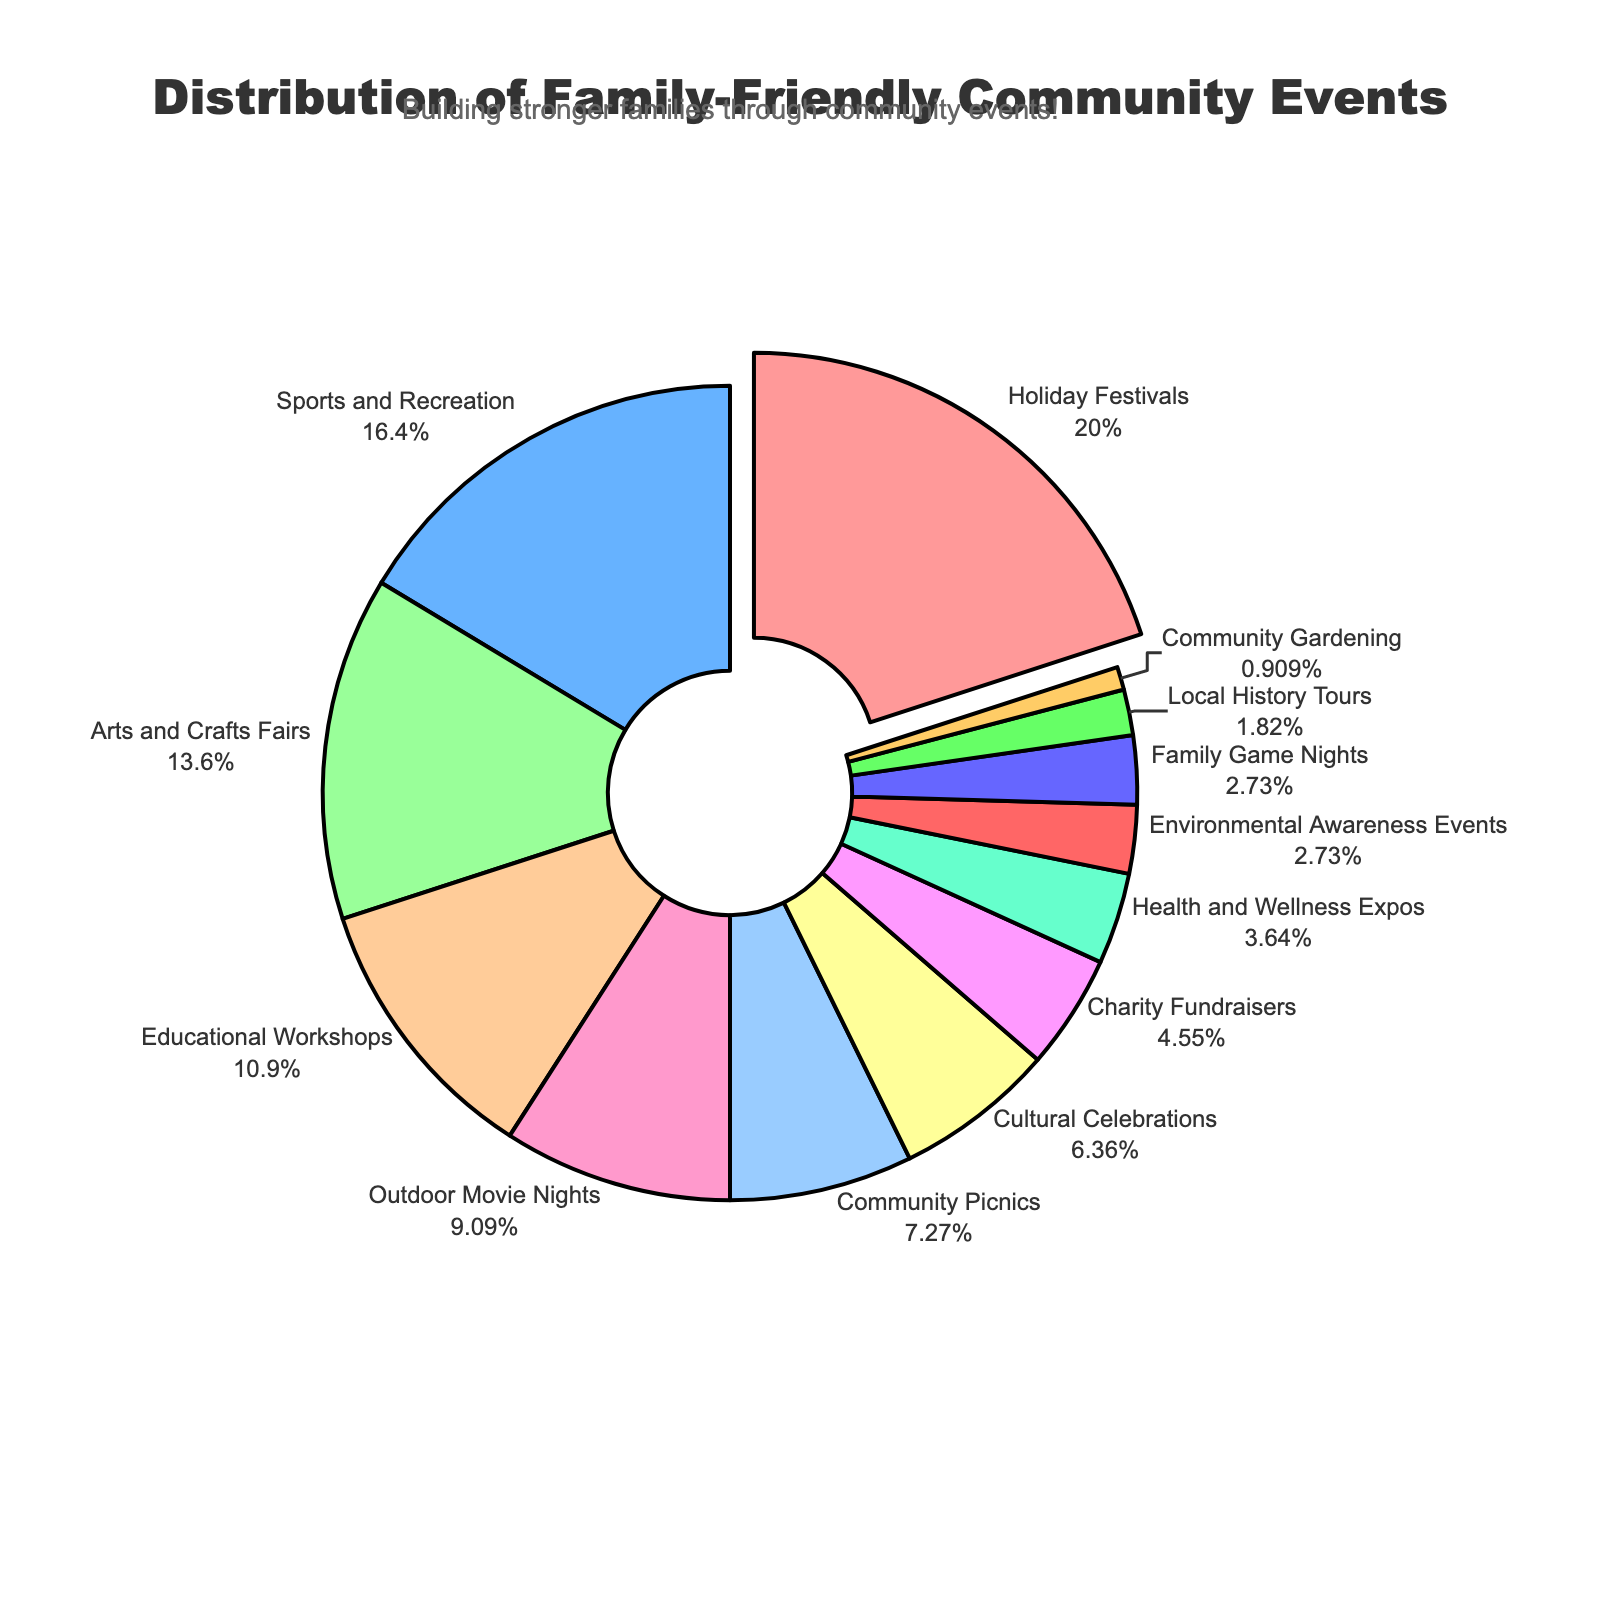What category has the largest percentage of events? The slice that is pulled slightly away from the pie represents the category with the largest percentage. This slice shows "Holiday Festivals" with 22%.
Answer: Holiday Festivals Which category has a smaller percentage, Sports and Recreation or Educational Workshops? "Sports and Recreation" has an 18% share, whereas "Educational Workshops" have a 12% share. Thus, Sports and Recreation has a larger percentage than Educational Workshops.
Answer: Educational Workshops What is the combined percentage of Community Picnics and Outdoor Movie Nights? Community Picnics account for 8%, and Outdoor Movie Nights account for 10%. Adding these two percentages gives 8% + 10% = 18%.
Answer: 18% How much larger is the percentage of Holiday Festivals compared to Charity Fundraisers? Holiday Festivals have a 22% share, while Charity Fundraisers have a 5% share. The difference between these percentages is 22% - 5% = 17%.
Answer: 17% What color represents the category with the smallest percentage? The category with the smallest percentage is Community Gardening with 1%. The chart shows this category in a color similar to a pale yellow.
Answer: Pale yellow Which two categories combined contribute exactly half of the total percentage? Holiday Festivals (22%) and Sports and Recreation (18%) combine to 40%, which is less than half. Adding Arts and Crafts Fairs to Holiday Festivals, we get 22% + 15% = 37%. Including Educational Workshops, we get 22% + 12% = 34%. Including both Arts and Workshops exceeds 50%. Thus, no two categories together sum to exactly 50%.
Answer: N/A What is the percentage difference between Cultural Celebrations and Environmental Awareness Events? Cultural Celebrations have 7%, and Environmental Awareness Events have 3%. The difference between these percentages is 7% - 3% = 4%.
Answer: 4% Which category is represented in blue, and what is its percentage? The category represented in blue, as indicated by the visual inspection, is "Community Picnics" with a share of 8%.
Answer: Community Picnics What is the percentage of categories related to outdoor activities (Sports and Recreation, Outdoor Movie Nights, Community Gardening, Community Picnics)? Adding the percentages for Sports and Recreation (18%), Outdoor Movie Nights (10%), Community Gardening (1%), and Community Picnics (8%) gives a combined percentage of 18% + 10% + 1% + 8% = 37%.
Answer: 37% What is the total percentage contribution of categories with less than 10%? Adding the percentages for Educational Workshops (12%) doesn't qualify, Outdoor Movie Nights (10%) qualifies to sum, Community Picnics (8%), Cultural Celebrations (7%), Charity Fundraisers (5%), Health and Wellness Expos (4%), Environmental Awareness Events (3%), Family Game Nights (3%), Local History Tours (2%), and Community Gardening (1%), we get 8% + 7% + 5% + 4% + 3% + 3% + 2% + 1% = 33%.
Answer: 33% 